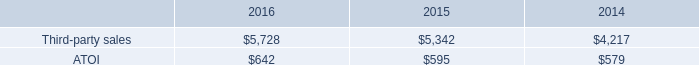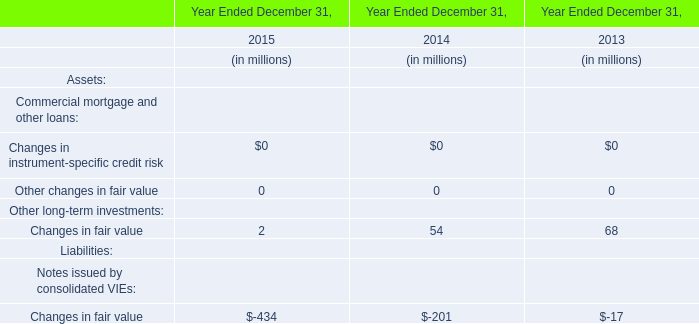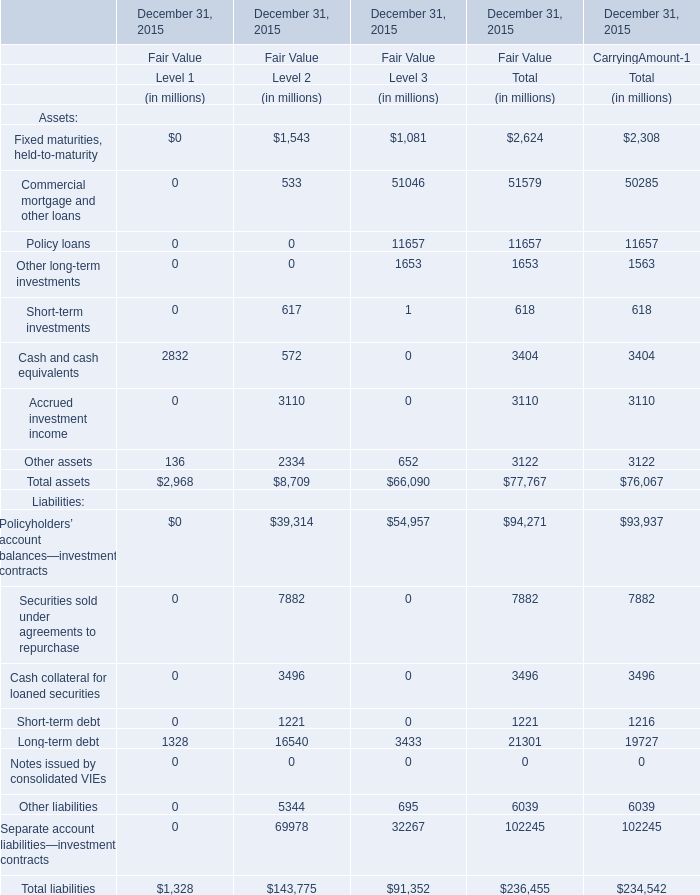what is the total amount of dollars received from aerospace end market sales in 2015? 
Computations: (5342 * 75%)
Answer: 4006.5. 